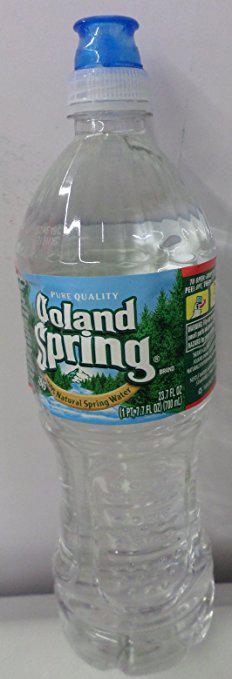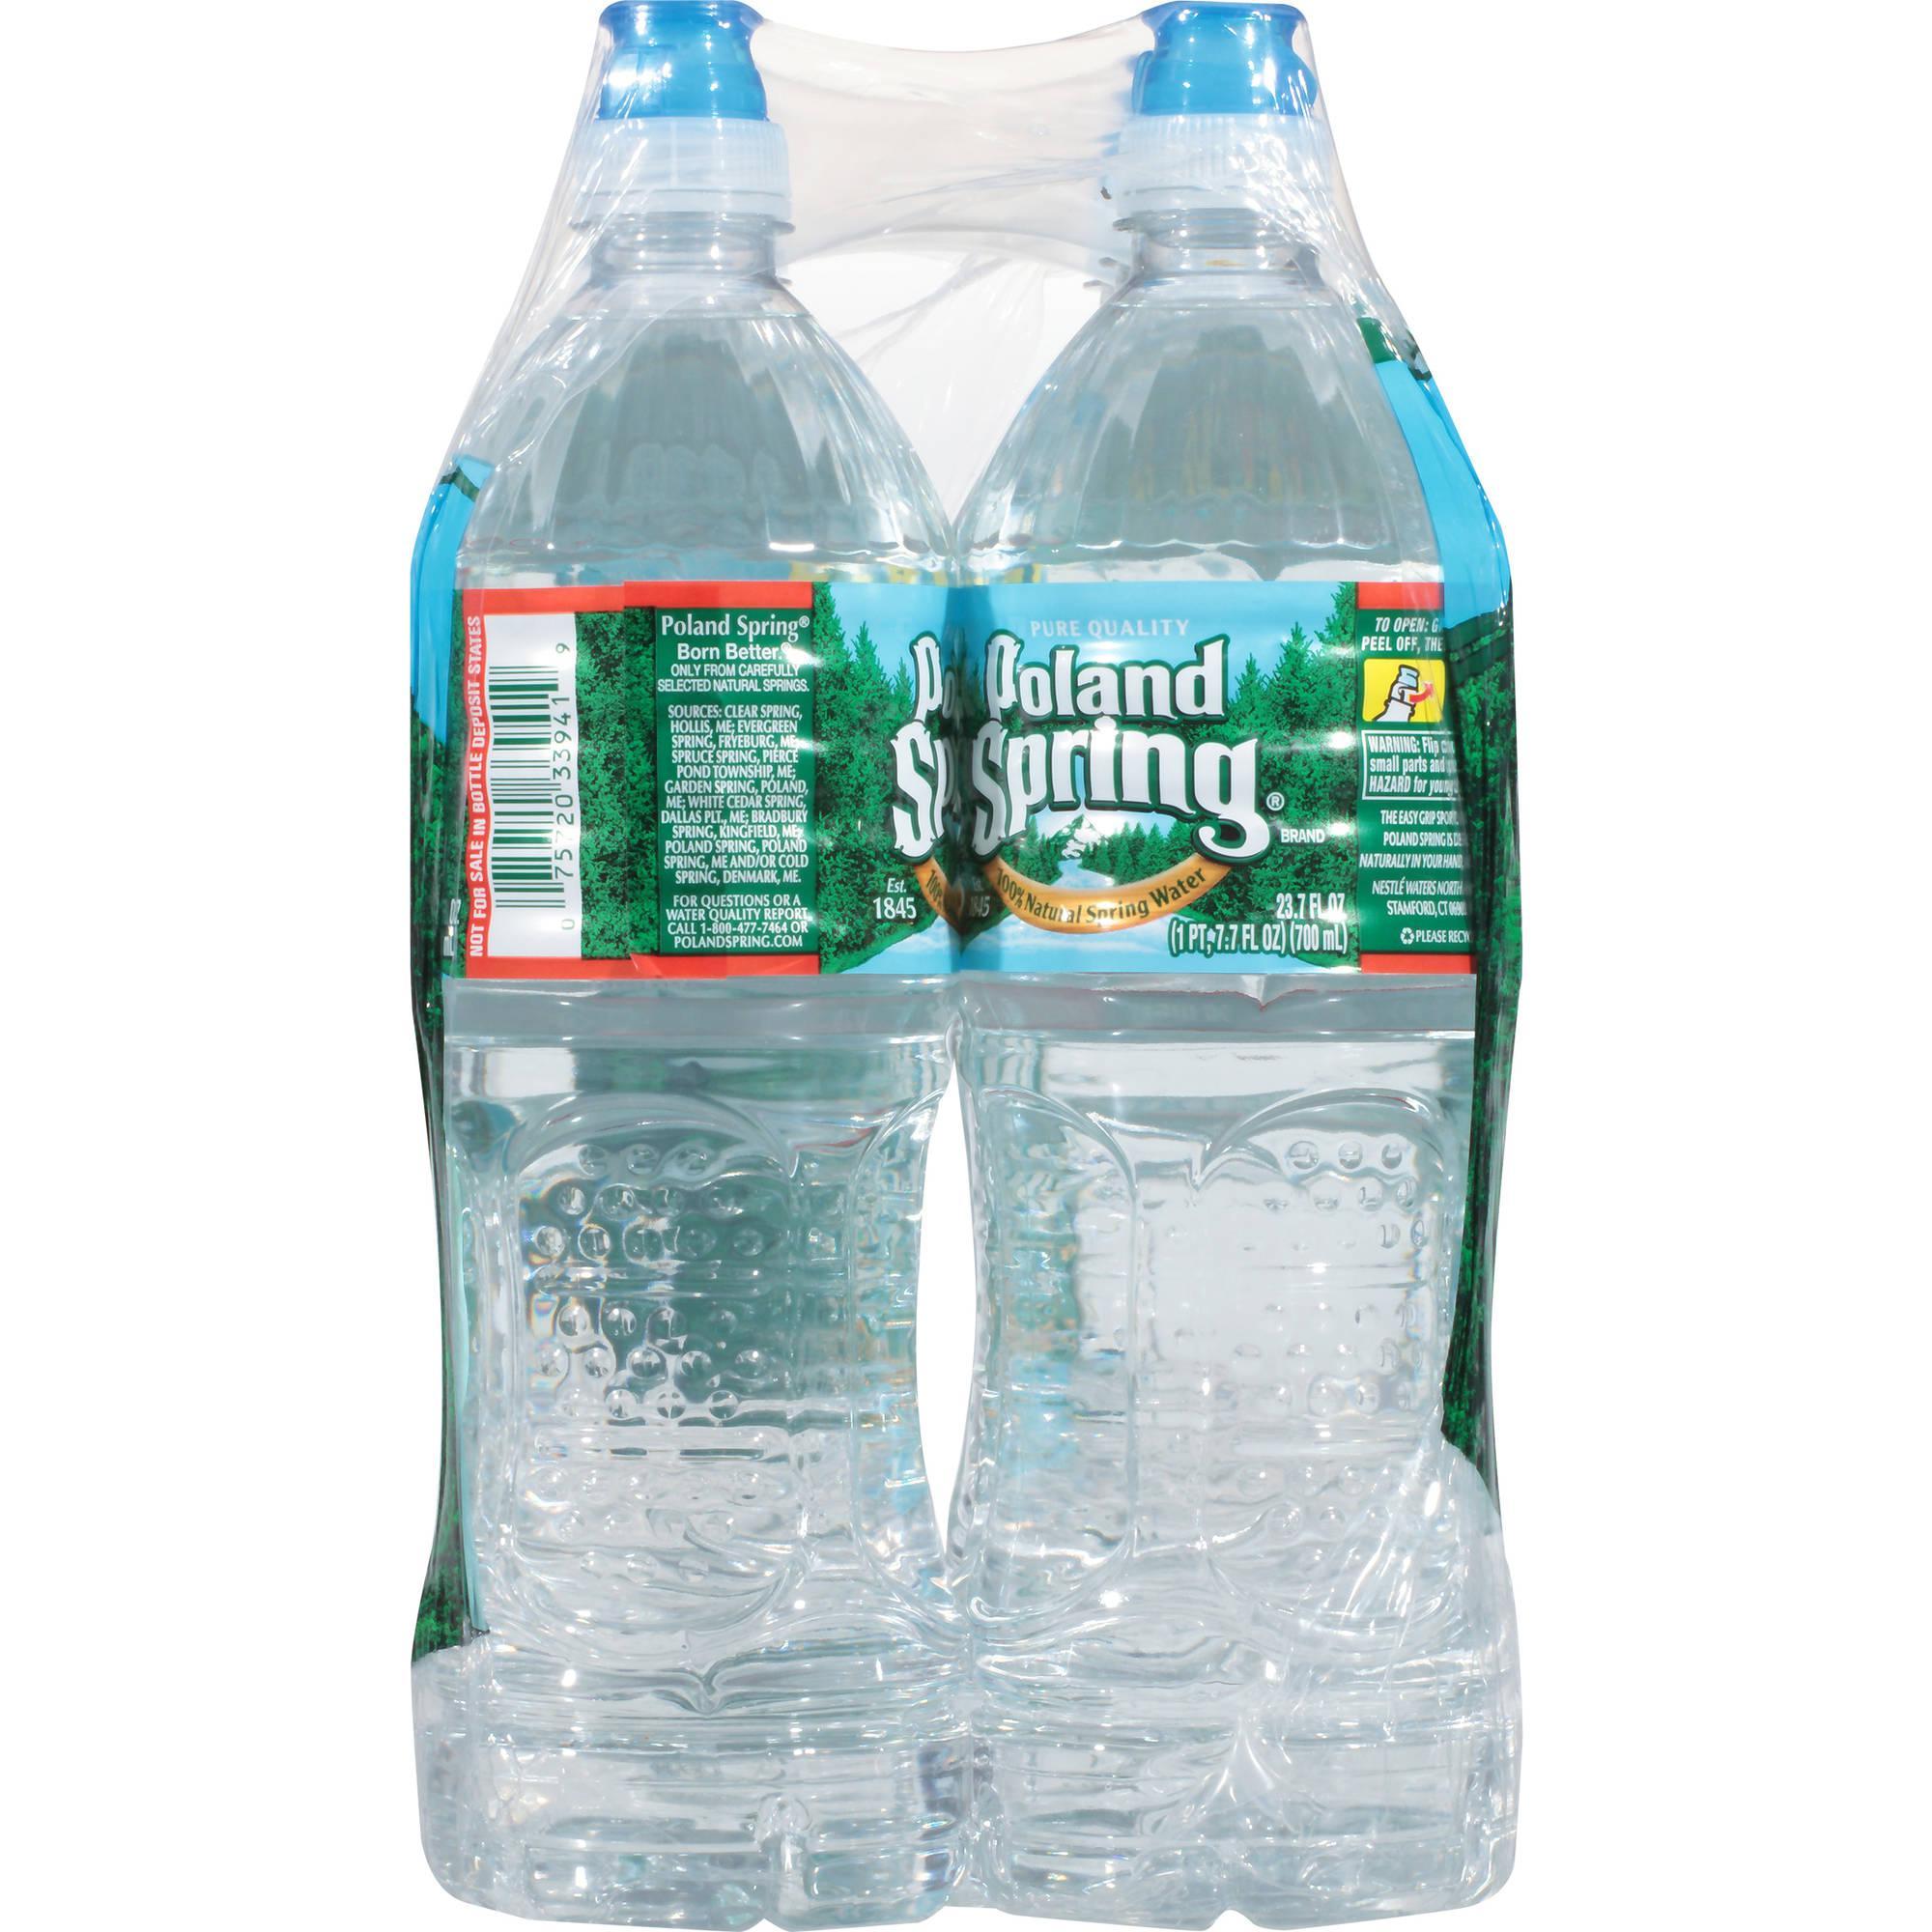The first image is the image on the left, the second image is the image on the right. Considering the images on both sides, is "At least one image shows a large mass of water bottles." valid? Answer yes or no. No. 